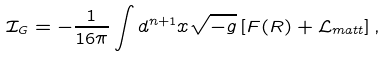<formula> <loc_0><loc_0><loc_500><loc_500>\mathcal { I } _ { G } = - \frac { 1 } { 1 6 \pi } \int d ^ { n + 1 } x \sqrt { - g } \left [ F ( R ) + \mathcal { L } _ { m a t t } \right ] ,</formula> 